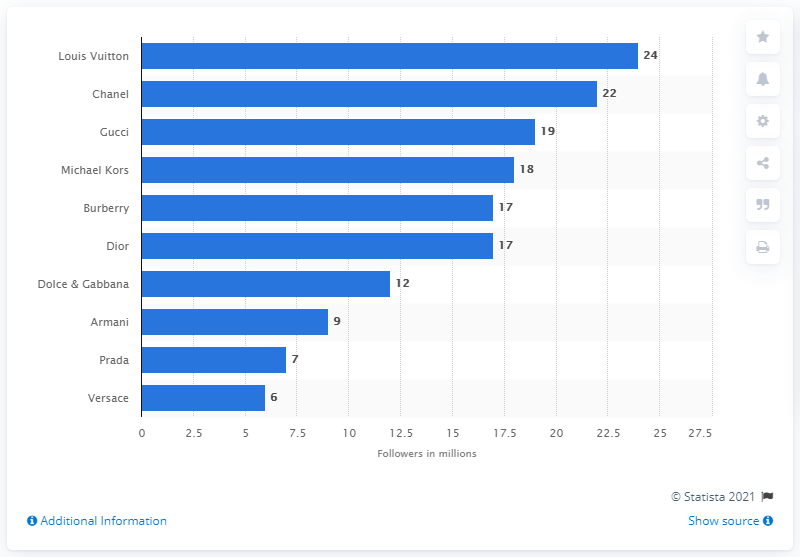Highlight a few significant elements in this photo. Louis Vuitton had approximately 24 users on Facebook. According to data, Chanel was the second-most popular luxury brand on Facebook in terms of number of followers. 